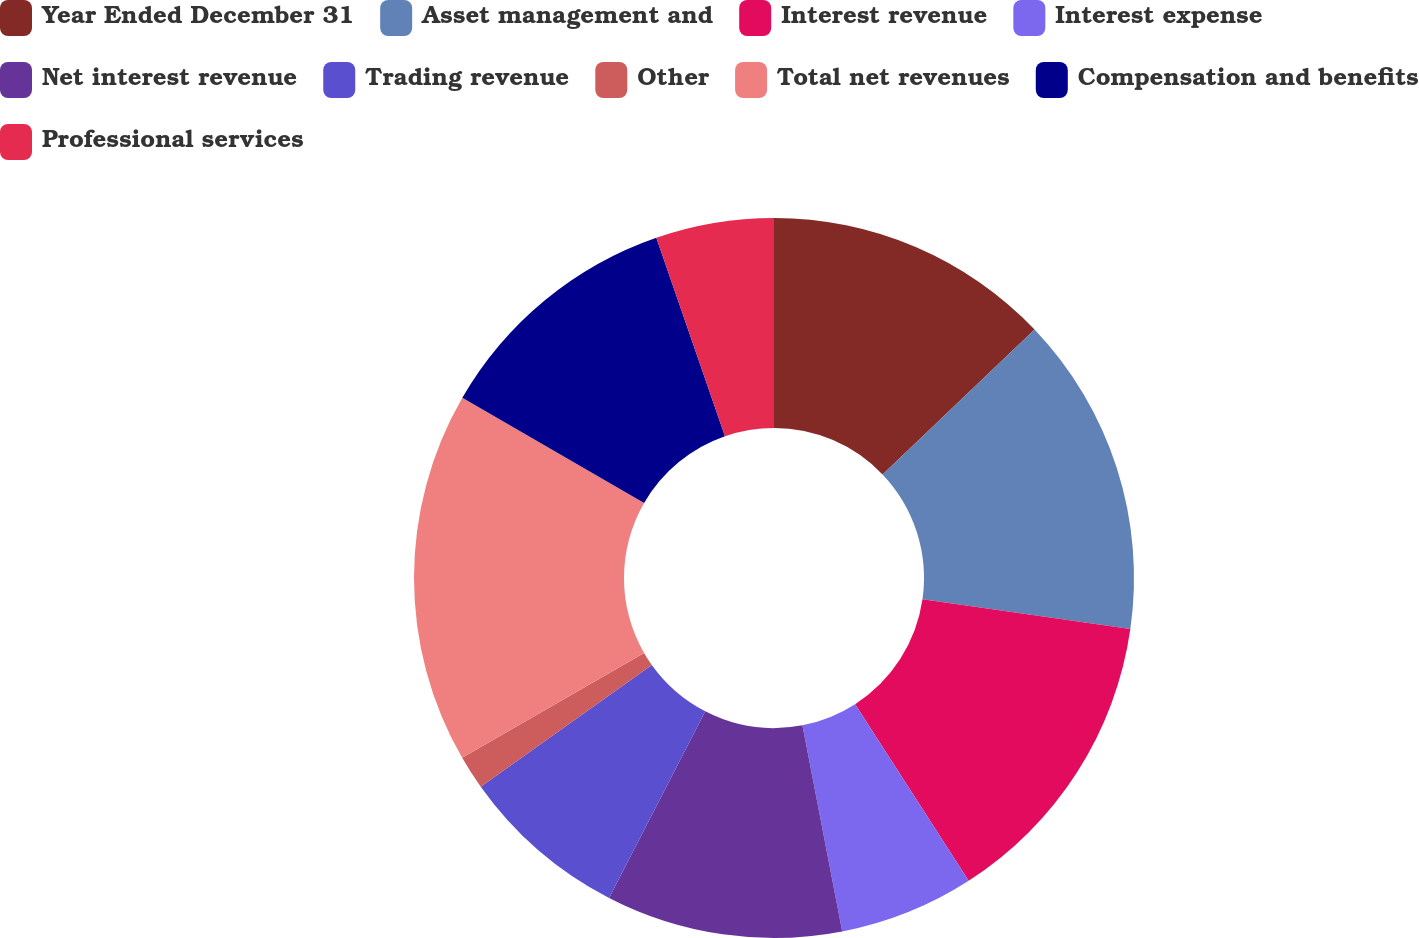<chart> <loc_0><loc_0><loc_500><loc_500><pie_chart><fcel>Year Ended December 31<fcel>Asset management and<fcel>Interest revenue<fcel>Interest expense<fcel>Net interest revenue<fcel>Trading revenue<fcel>Other<fcel>Total net revenues<fcel>Compensation and benefits<fcel>Professional services<nl><fcel>12.88%<fcel>14.39%<fcel>13.64%<fcel>6.06%<fcel>10.61%<fcel>7.58%<fcel>1.52%<fcel>16.67%<fcel>11.36%<fcel>5.3%<nl></chart> 